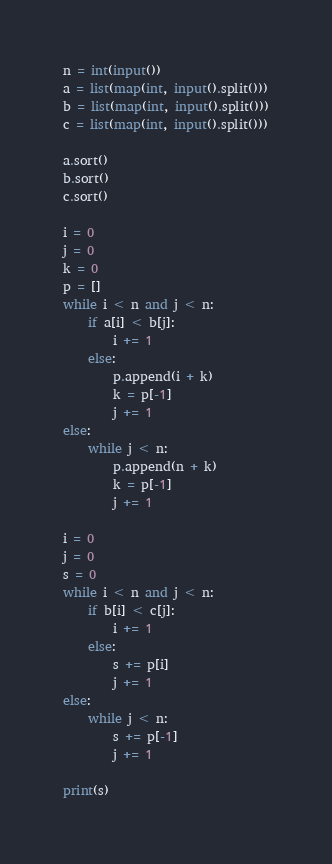<code> <loc_0><loc_0><loc_500><loc_500><_Python_>n = int(input())
a = list(map(int, input().split()))
b = list(map(int, input().split()))
c = list(map(int, input().split()))

a.sort()
b.sort()
c.sort()

i = 0
j = 0
k = 0
p = []
while i < n and j < n:
    if a[i] < b[j]:
        i += 1
    else:
        p.append(i + k)
        k = p[-1]
        j += 1
else:
    while j < n:
        p.append(n + k)
        k = p[-1]
        j += 1

i = 0
j = 0
s = 0
while i < n and j < n:
    if b[i] < c[j]:
        i += 1
    else:
        s += p[i]
        j += 1
else:
    while j < n:
        s += p[-1]
        j += 1

print(s)</code> 